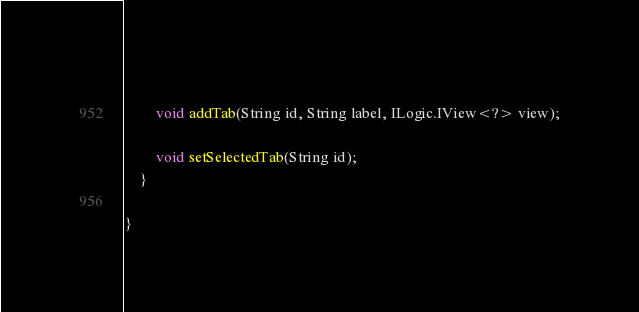<code> <loc_0><loc_0><loc_500><loc_500><_Java_>		
		void addTab(String id, String label, ILogic.IView<?> view);

		void setSelectedTab(String id);
	}

}
</code> 